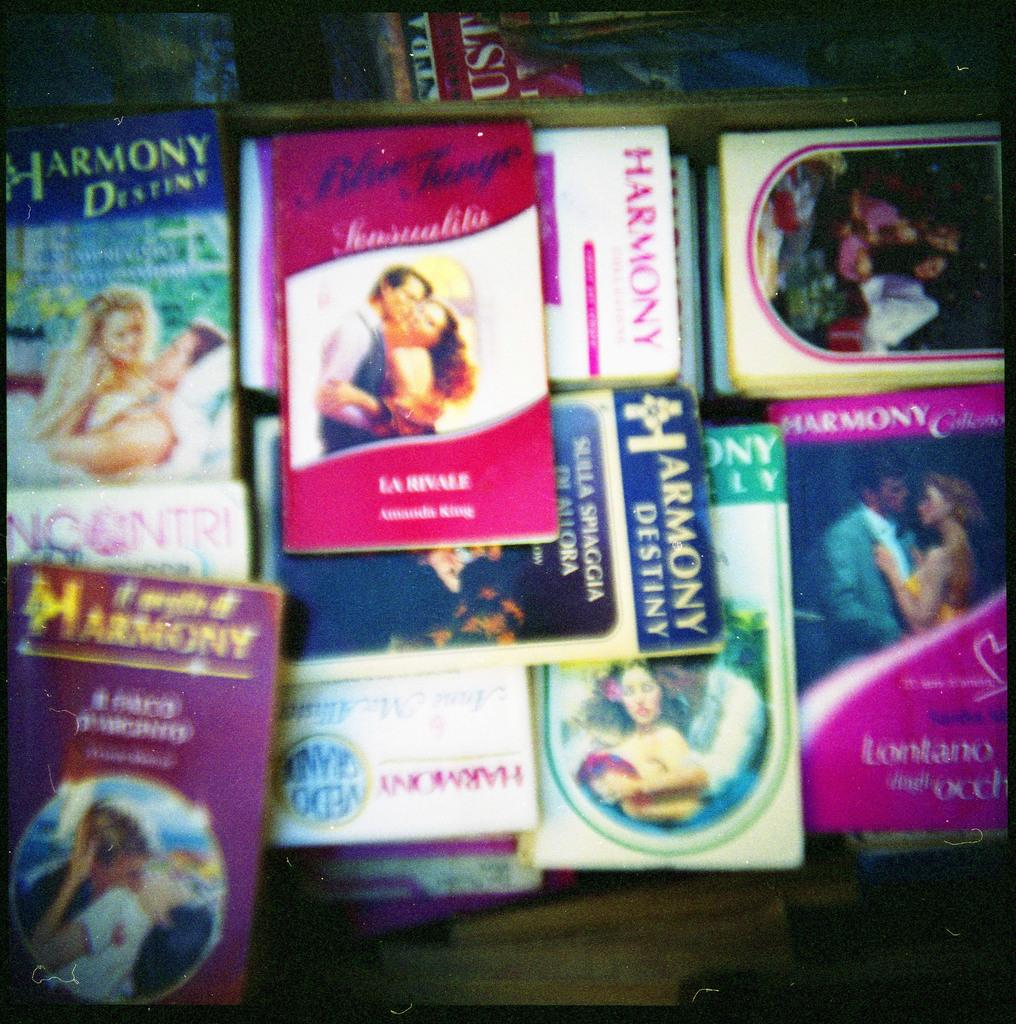<image>
Share a concise interpretation of the image provided. Many books are stacked on top of each other with a book called Harmony under another book. 